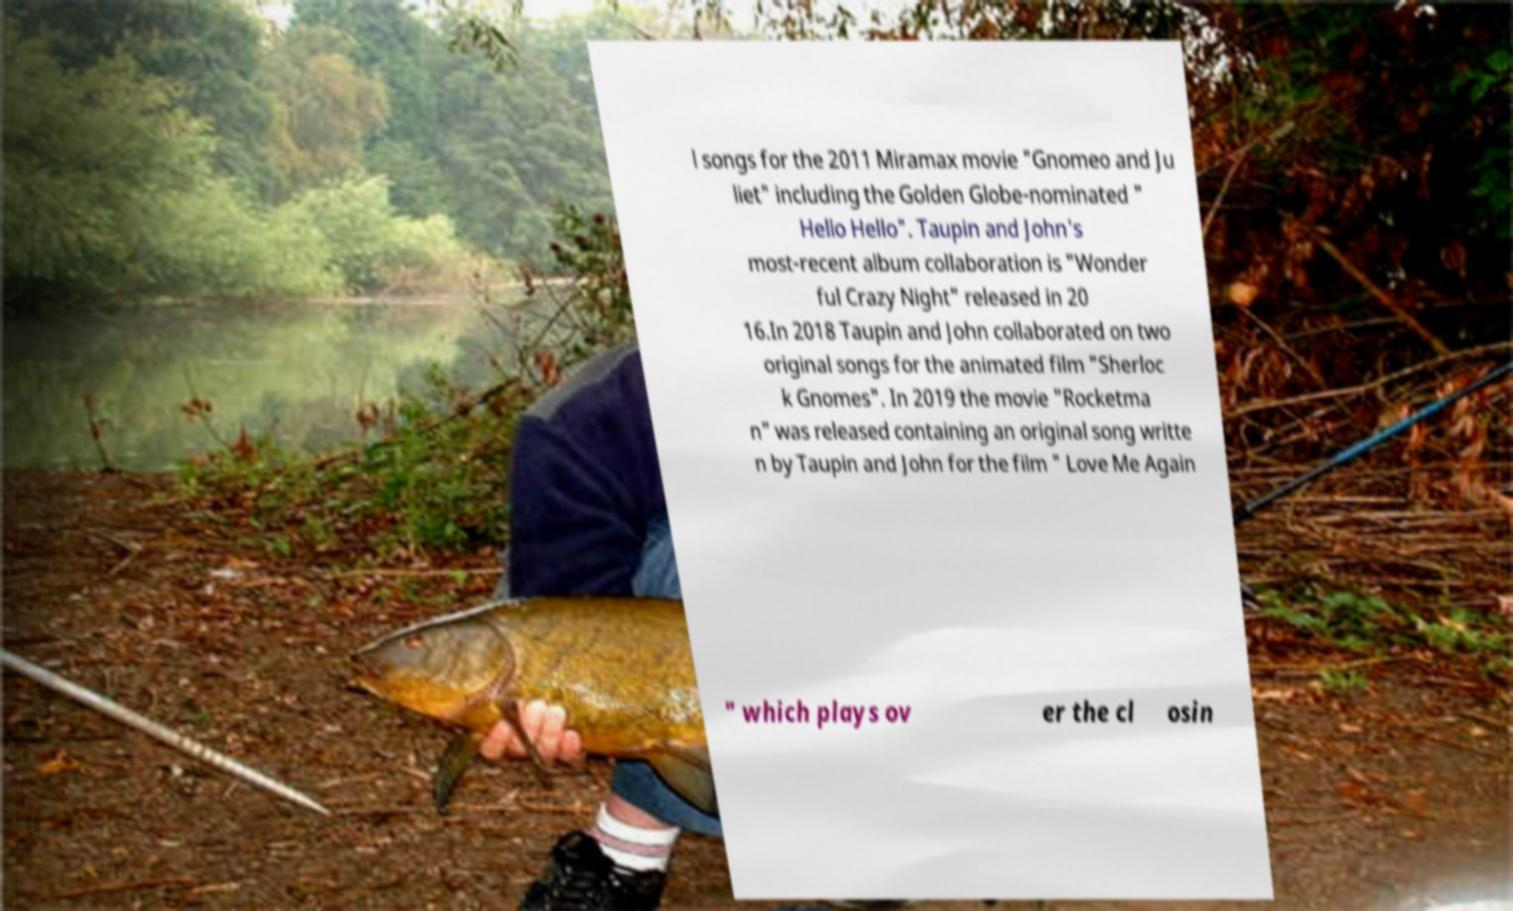Could you assist in decoding the text presented in this image and type it out clearly? l songs for the 2011 Miramax movie "Gnomeo and Ju liet" including the Golden Globe-nominated " Hello Hello". Taupin and John's most-recent album collaboration is "Wonder ful Crazy Night" released in 20 16.In 2018 Taupin and John collaborated on two original songs for the animated film "Sherloc k Gnomes". In 2019 the movie "Rocketma n" was released containing an original song writte n by Taupin and John for the film " Love Me Again " which plays ov er the cl osin 